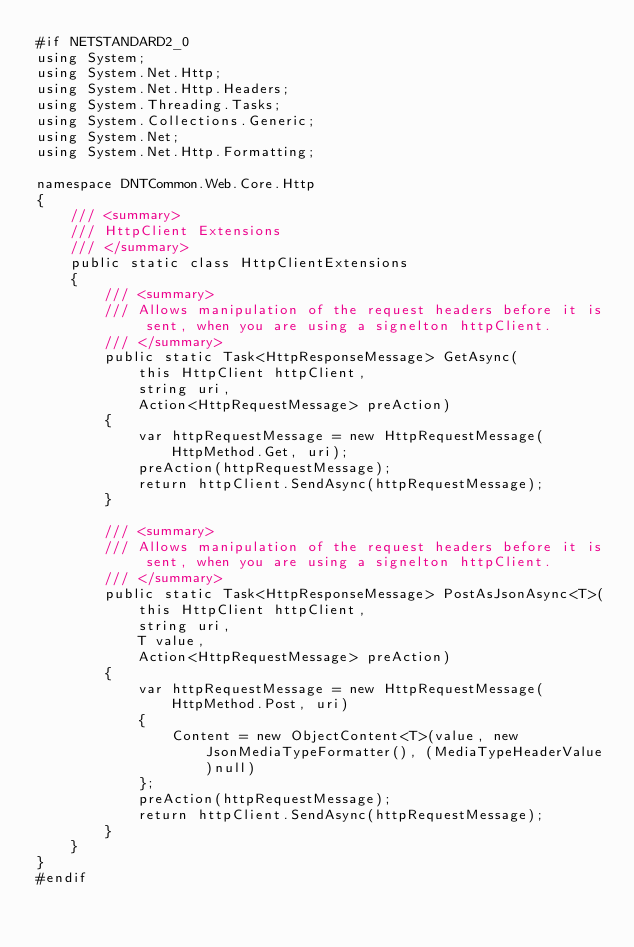Convert code to text. <code><loc_0><loc_0><loc_500><loc_500><_C#_>#if NETSTANDARD2_0
using System;
using System.Net.Http;
using System.Net.Http.Headers;
using System.Threading.Tasks;
using System.Collections.Generic;
using System.Net;
using System.Net.Http.Formatting;

namespace DNTCommon.Web.Core.Http
{
    /// <summary>
    /// HttpClient Extensions
    /// </summary>
    public static class HttpClientExtensions
    {
        /// <summary>
        /// Allows manipulation of the request headers before it is sent, when you are using a signelton httpClient.
        /// </summary>
        public static Task<HttpResponseMessage> GetAsync(
            this HttpClient httpClient,
            string uri,
            Action<HttpRequestMessage> preAction)
        {
            var httpRequestMessage = new HttpRequestMessage(HttpMethod.Get, uri);
            preAction(httpRequestMessage);
            return httpClient.SendAsync(httpRequestMessage);
        }

        /// <summary>
        /// Allows manipulation of the request headers before it is sent, when you are using a signelton httpClient.
        /// </summary>
        public static Task<HttpResponseMessage> PostAsJsonAsync<T>(
            this HttpClient httpClient,
            string uri,
            T value,
            Action<HttpRequestMessage> preAction)
        {
            var httpRequestMessage = new HttpRequestMessage(HttpMethod.Post, uri)
            {
                Content = new ObjectContent<T>(value, new JsonMediaTypeFormatter(), (MediaTypeHeaderValue)null)
            };
            preAction(httpRequestMessage);
            return httpClient.SendAsync(httpRequestMessage);
        }
    }
}
#endif</code> 